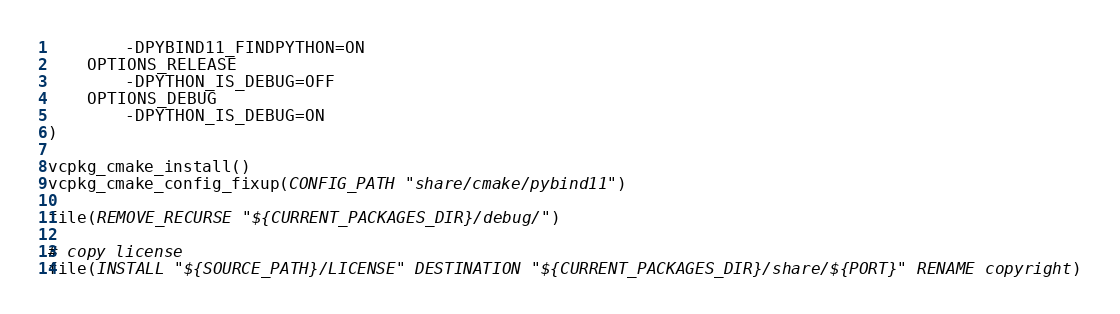<code> <loc_0><loc_0><loc_500><loc_500><_CMake_>        -DPYBIND11_FINDPYTHON=ON
    OPTIONS_RELEASE
        -DPYTHON_IS_DEBUG=OFF
    OPTIONS_DEBUG
        -DPYTHON_IS_DEBUG=ON
)

vcpkg_cmake_install()
vcpkg_cmake_config_fixup(CONFIG_PATH "share/cmake/pybind11")

file(REMOVE_RECURSE "${CURRENT_PACKAGES_DIR}/debug/")

# copy license
file(INSTALL "${SOURCE_PATH}/LICENSE" DESTINATION "${CURRENT_PACKAGES_DIR}/share/${PORT}" RENAME copyright)
</code> 